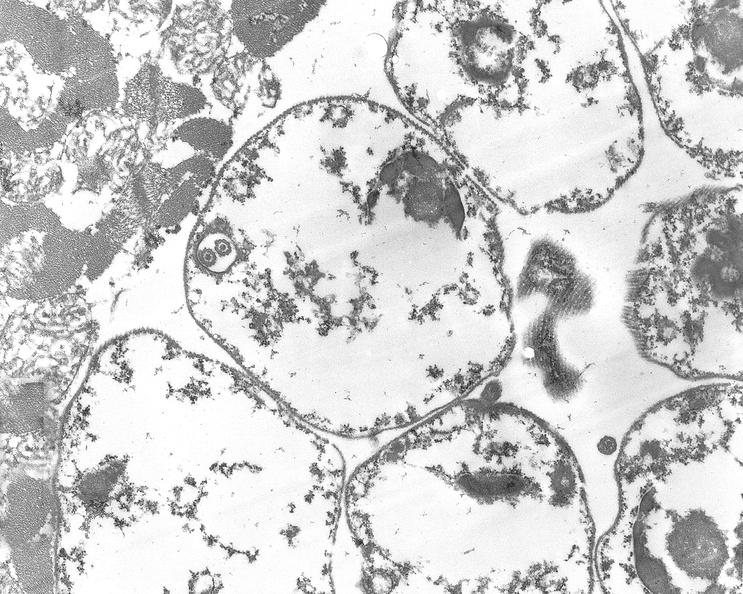does carcinoma show chagas disease, acute, trypanasoma cruzi?
Answer the question using a single word or phrase. No 